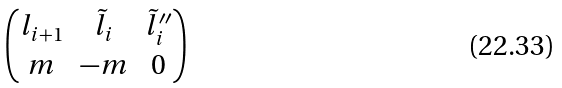Convert formula to latex. <formula><loc_0><loc_0><loc_500><loc_500>\begin{pmatrix} l _ { i + 1 } & \tilde { l } _ { i } & \tilde { l } _ { i } ^ { \prime \prime } \\ m & - m & 0 \end{pmatrix}</formula> 